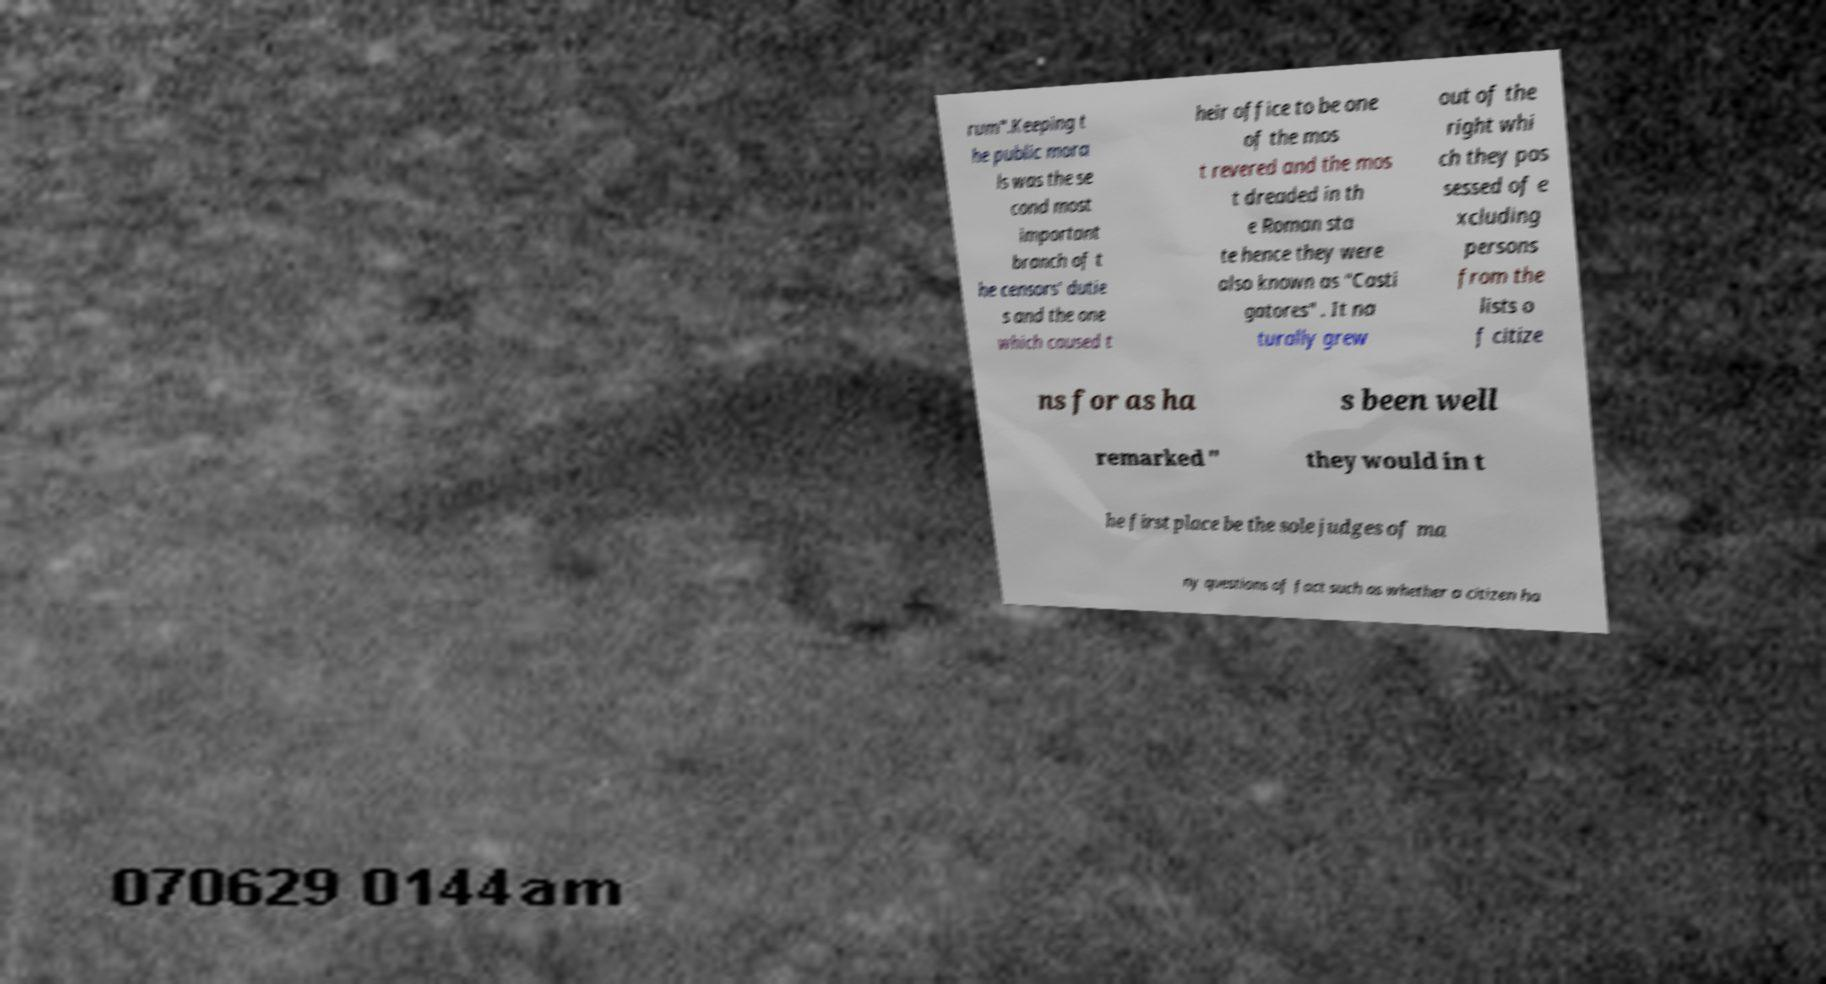What messages or text are displayed in this image? I need them in a readable, typed format. rum".Keeping t he public mora ls was the se cond most important branch of t he censors' dutie s and the one which caused t heir office to be one of the mos t revered and the mos t dreaded in th e Roman sta te hence they were also known as "Casti gatores" . It na turally grew out of the right whi ch they pos sessed of e xcluding persons from the lists o f citize ns for as ha s been well remarked " they would in t he first place be the sole judges of ma ny questions of fact such as whether a citizen ha 